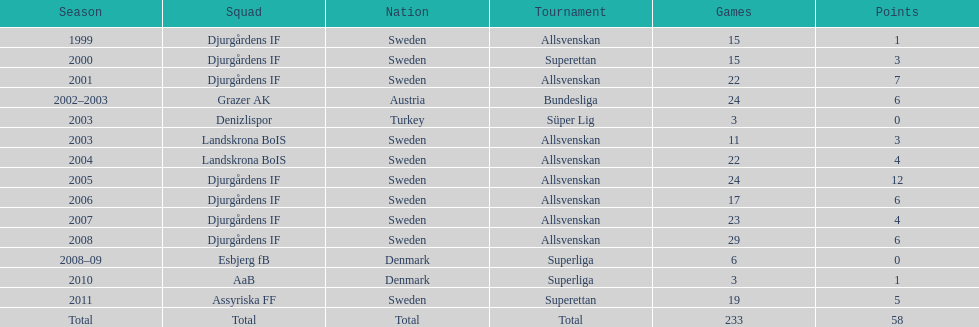What season has the most goals? 2005. Would you be able to parse every entry in this table? {'header': ['Season', 'Squad', 'Nation', 'Tournament', 'Games', 'Points'], 'rows': [['1999', 'Djurgårdens IF', 'Sweden', 'Allsvenskan', '15', '1'], ['2000', 'Djurgårdens IF', 'Sweden', 'Superettan', '15', '3'], ['2001', 'Djurgårdens IF', 'Sweden', 'Allsvenskan', '22', '7'], ['2002–2003', 'Grazer AK', 'Austria', 'Bundesliga', '24', '6'], ['2003', 'Denizlispor', 'Turkey', 'Süper Lig', '3', '0'], ['2003', 'Landskrona BoIS', 'Sweden', 'Allsvenskan', '11', '3'], ['2004', 'Landskrona BoIS', 'Sweden', 'Allsvenskan', '22', '4'], ['2005', 'Djurgårdens IF', 'Sweden', 'Allsvenskan', '24', '12'], ['2006', 'Djurgårdens IF', 'Sweden', 'Allsvenskan', '17', '6'], ['2007', 'Djurgårdens IF', 'Sweden', 'Allsvenskan', '23', '4'], ['2008', 'Djurgårdens IF', 'Sweden', 'Allsvenskan', '29', '6'], ['2008–09', 'Esbjerg fB', 'Denmark', 'Superliga', '6', '0'], ['2010', 'AaB', 'Denmark', 'Superliga', '3', '1'], ['2011', 'Assyriska FF', 'Sweden', 'Superettan', '19', '5'], ['Total', 'Total', 'Total', 'Total', '233', '58']]} 